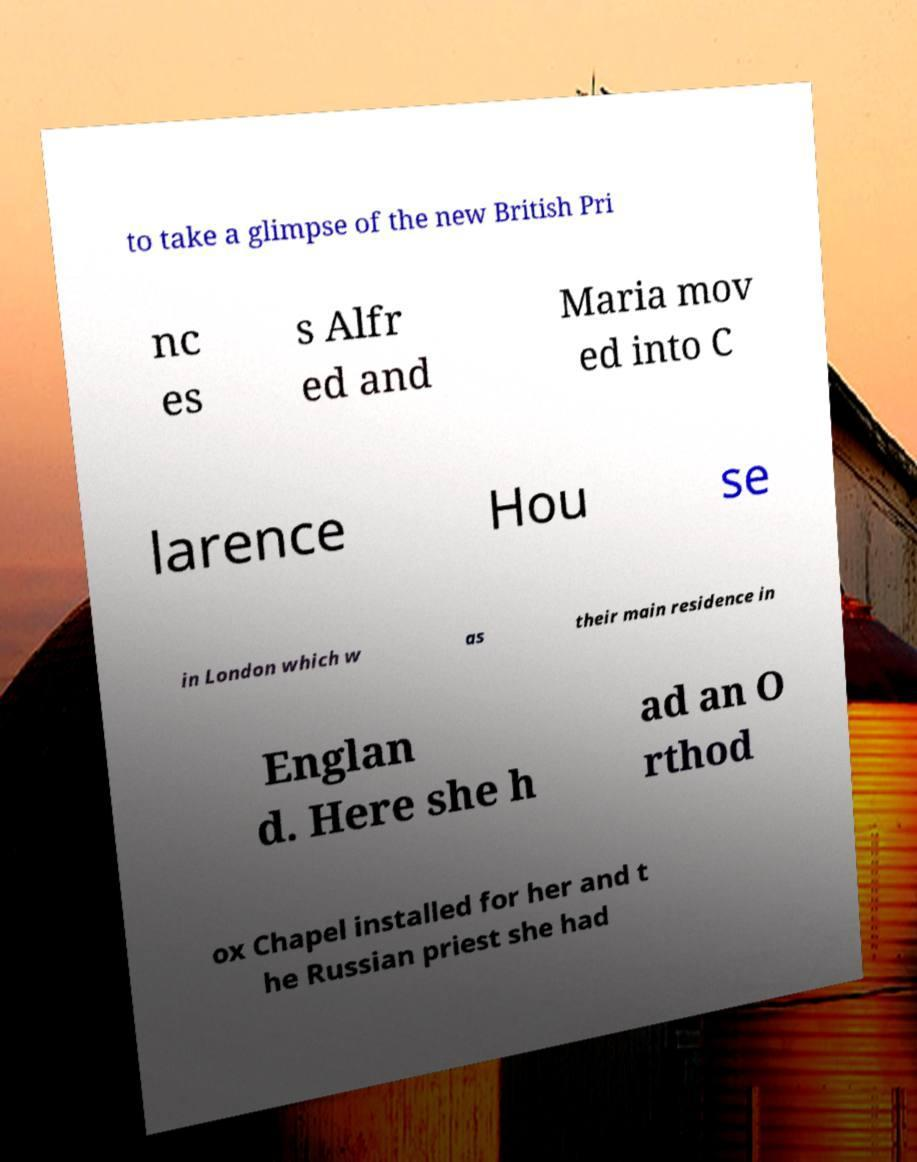There's text embedded in this image that I need extracted. Can you transcribe it verbatim? to take a glimpse of the new British Pri nc es s Alfr ed and Maria mov ed into C larence Hou se in London which w as their main residence in Englan d. Here she h ad an O rthod ox Chapel installed for her and t he Russian priest she had 